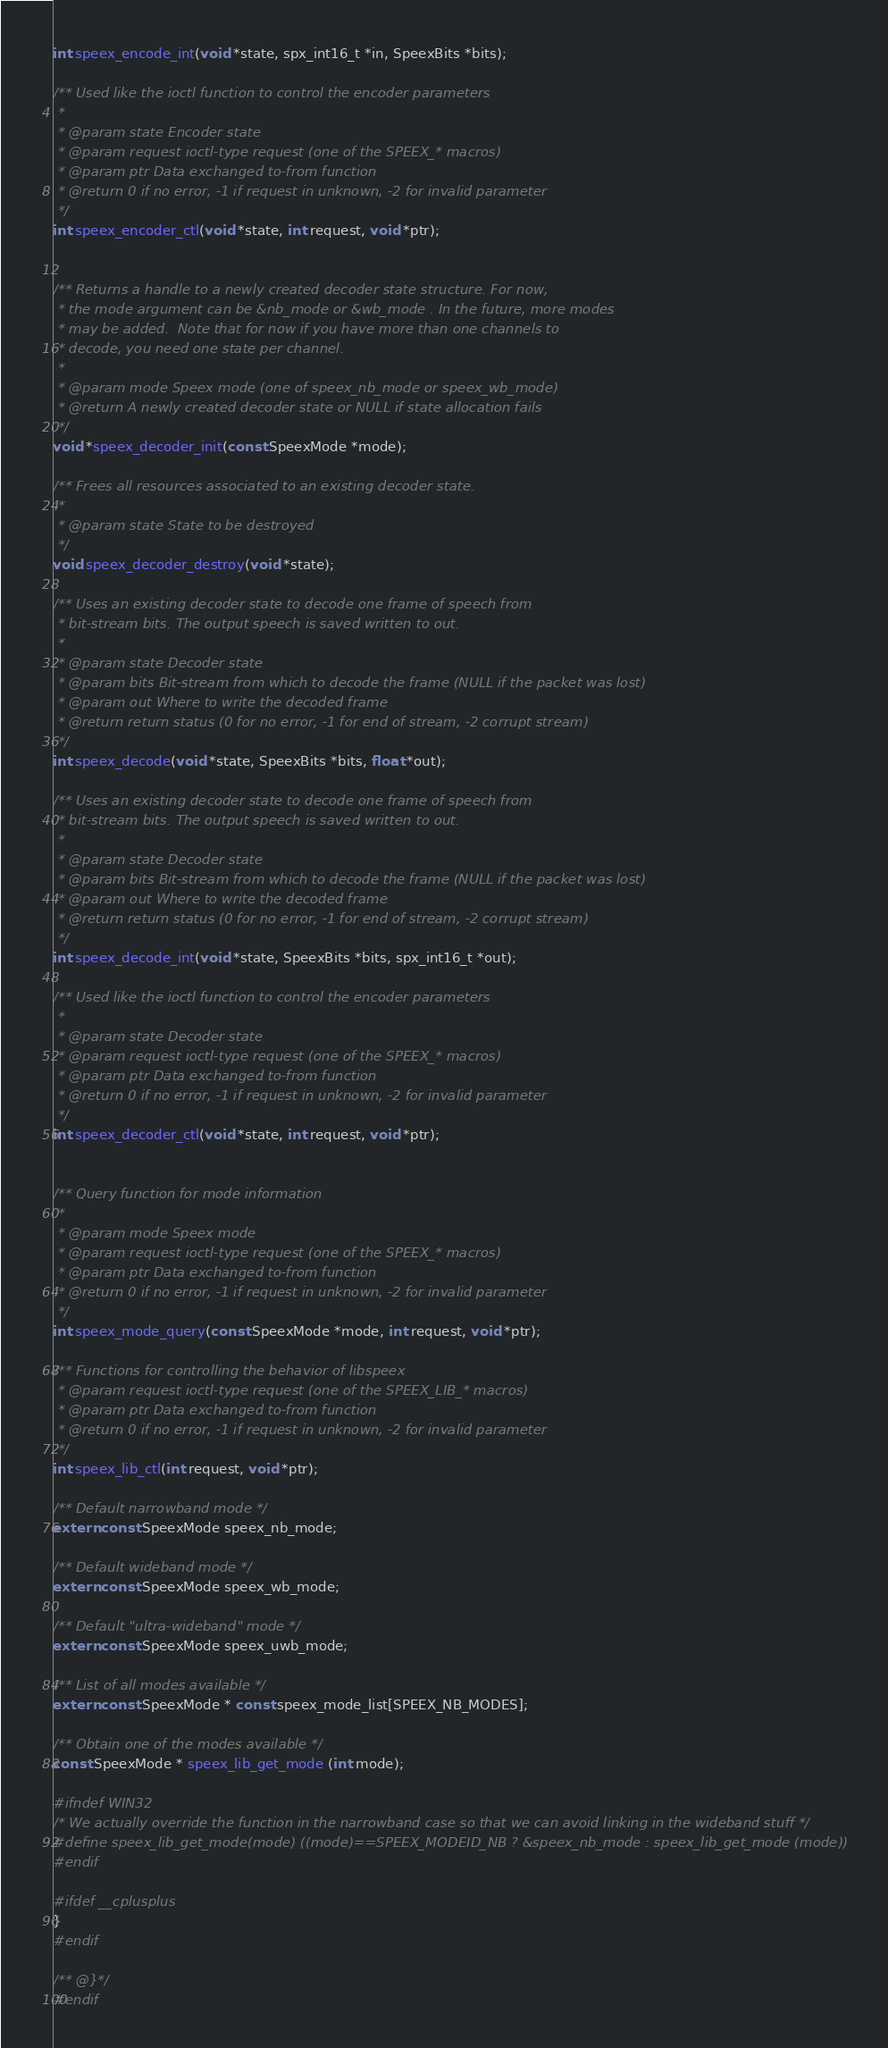Convert code to text. <code><loc_0><loc_0><loc_500><loc_500><_C_>int speex_encode_int(void *state, spx_int16_t *in, SpeexBits *bits);

/** Used like the ioctl function to control the encoder parameters
 *
 * @param state Encoder state
 * @param request ioctl-type request (one of the SPEEX_* macros)
 * @param ptr Data exchanged to-from function
 * @return 0 if no error, -1 if request in unknown, -2 for invalid parameter
 */
int speex_encoder_ctl(void *state, int request, void *ptr);


/** Returns a handle to a newly created decoder state structure. For now, 
 * the mode argument can be &nb_mode or &wb_mode . In the future, more modes
 * may be added.  Note that for now if you have more than one channels to
 * decode, you need one state per channel.
 *
 * @param mode Speex mode (one of speex_nb_mode or speex_wb_mode)
 * @return A newly created decoder state or NULL if state allocation fails
 */ 
void *speex_decoder_init(const SpeexMode *mode);

/** Frees all resources associated to an existing decoder state.
 *
 * @param state State to be destroyed
 */
void speex_decoder_destroy(void *state);

/** Uses an existing decoder state to decode one frame of speech from
 * bit-stream bits. The output speech is saved written to out.
 *
 * @param state Decoder state
 * @param bits Bit-stream from which to decode the frame (NULL if the packet was lost)
 * @param out Where to write the decoded frame
 * @return return status (0 for no error, -1 for end of stream, -2 corrupt stream)
 */
int speex_decode(void *state, SpeexBits *bits, float *out);

/** Uses an existing decoder state to decode one frame of speech from
 * bit-stream bits. The output speech is saved written to out.
 *
 * @param state Decoder state
 * @param bits Bit-stream from which to decode the frame (NULL if the packet was lost)
 * @param out Where to write the decoded frame
 * @return return status (0 for no error, -1 for end of stream, -2 corrupt stream)
 */
int speex_decode_int(void *state, SpeexBits *bits, spx_int16_t *out);

/** Used like the ioctl function to control the encoder parameters
 *
 * @param state Decoder state
 * @param request ioctl-type request (one of the SPEEX_* macros)
 * @param ptr Data exchanged to-from function
 * @return 0 if no error, -1 if request in unknown, -2 for invalid parameter
 */
int speex_decoder_ctl(void *state, int request, void *ptr);


/** Query function for mode information
 *
 * @param mode Speex mode
 * @param request ioctl-type request (one of the SPEEX_* macros)
 * @param ptr Data exchanged to-from function
 * @return 0 if no error, -1 if request in unknown, -2 for invalid parameter
 */
int speex_mode_query(const SpeexMode *mode, int request, void *ptr);

/** Functions for controlling the behavior of libspeex
 * @param request ioctl-type request (one of the SPEEX_LIB_* macros)
 * @param ptr Data exchanged to-from function
 * @return 0 if no error, -1 if request in unknown, -2 for invalid parameter
 */
int speex_lib_ctl(int request, void *ptr);

/** Default narrowband mode */
extern const SpeexMode speex_nb_mode;

/** Default wideband mode */
extern const SpeexMode speex_wb_mode;

/** Default "ultra-wideband" mode */
extern const SpeexMode speex_uwb_mode;

/** List of all modes available */
extern const SpeexMode * const speex_mode_list[SPEEX_NB_MODES];

/** Obtain one of the modes available */
const SpeexMode * speex_lib_get_mode (int mode);

#ifndef WIN32
/* We actually override the function in the narrowband case so that we can avoid linking in the wideband stuff */
#define speex_lib_get_mode(mode) ((mode)==SPEEX_MODEID_NB ? &speex_nb_mode : speex_lib_get_mode (mode))
#endif

#ifdef __cplusplus
}
#endif

/** @}*/
#endif
</code> 